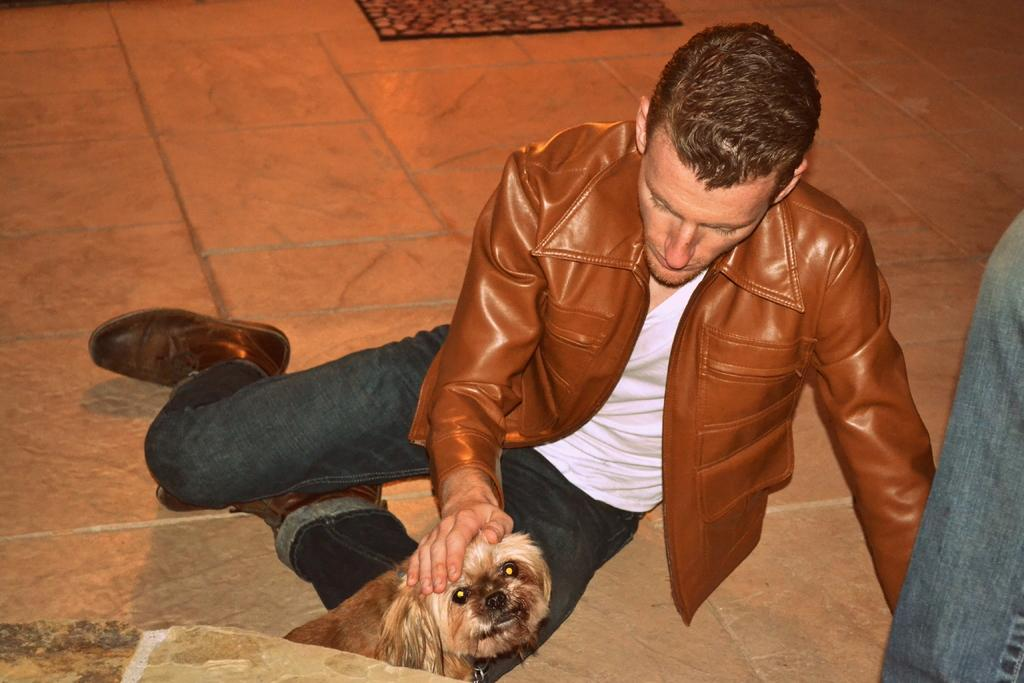What is the main subject of the image? There is a man in the image. What is the man doing in the image? The man is sitting on the floor. Are there any other living beings in the image besides the man? Yes, there is a dog in the image. What type of leather is the man using to play with the fowl in the image? There is no leather or fowl present in the image. How many bells can be heard ringing in the background of the image? There are no bells present in the image, so it is not possible to determine how many can be heard. 